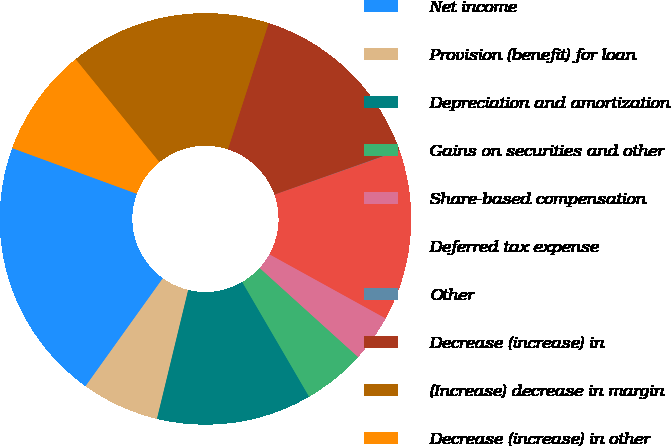<chart> <loc_0><loc_0><loc_500><loc_500><pie_chart><fcel>Net income<fcel>Provision (benefit) for loan<fcel>Depreciation and amortization<fcel>Gains on securities and other<fcel>Share-based compensation<fcel>Deferred tax expense<fcel>Other<fcel>Decrease (increase) in<fcel>(Increase) decrease in margin<fcel>Decrease (increase) in other<nl><fcel>20.7%<fcel>6.11%<fcel>12.19%<fcel>4.89%<fcel>3.68%<fcel>13.41%<fcel>0.03%<fcel>14.62%<fcel>15.84%<fcel>8.54%<nl></chart> 